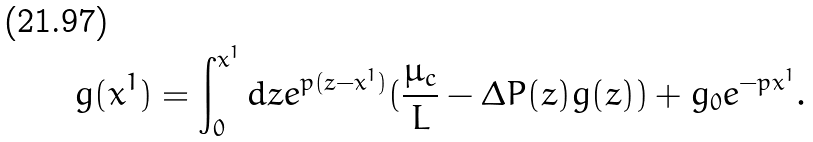Convert formula to latex. <formula><loc_0><loc_0><loc_500><loc_500>g ( x ^ { 1 } ) = \int _ { 0 } ^ { x ^ { 1 } } d z e ^ { p ( z - x ^ { 1 } ) } ( \frac { \mu _ { c } } { L } - \Delta P ( z ) g ( z ) ) + g _ { 0 } e ^ { - p x ^ { 1 } } .</formula> 